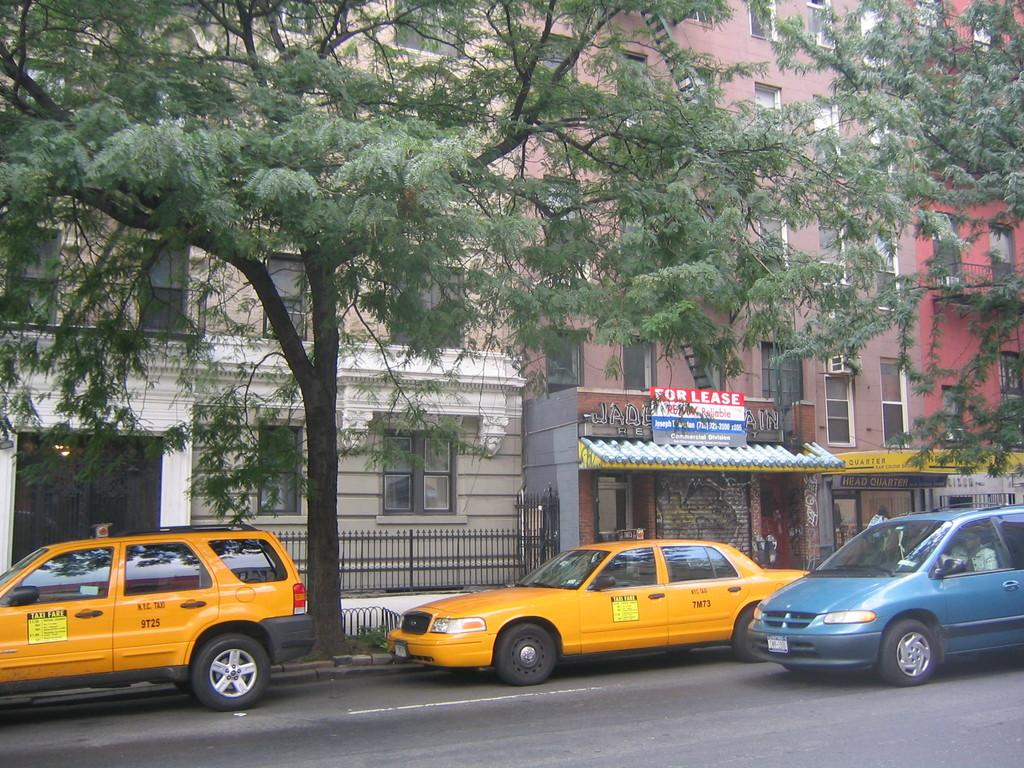<image>
Write a terse but informative summary of the picture. A "FOR LEASE" sign is above a taxi. 